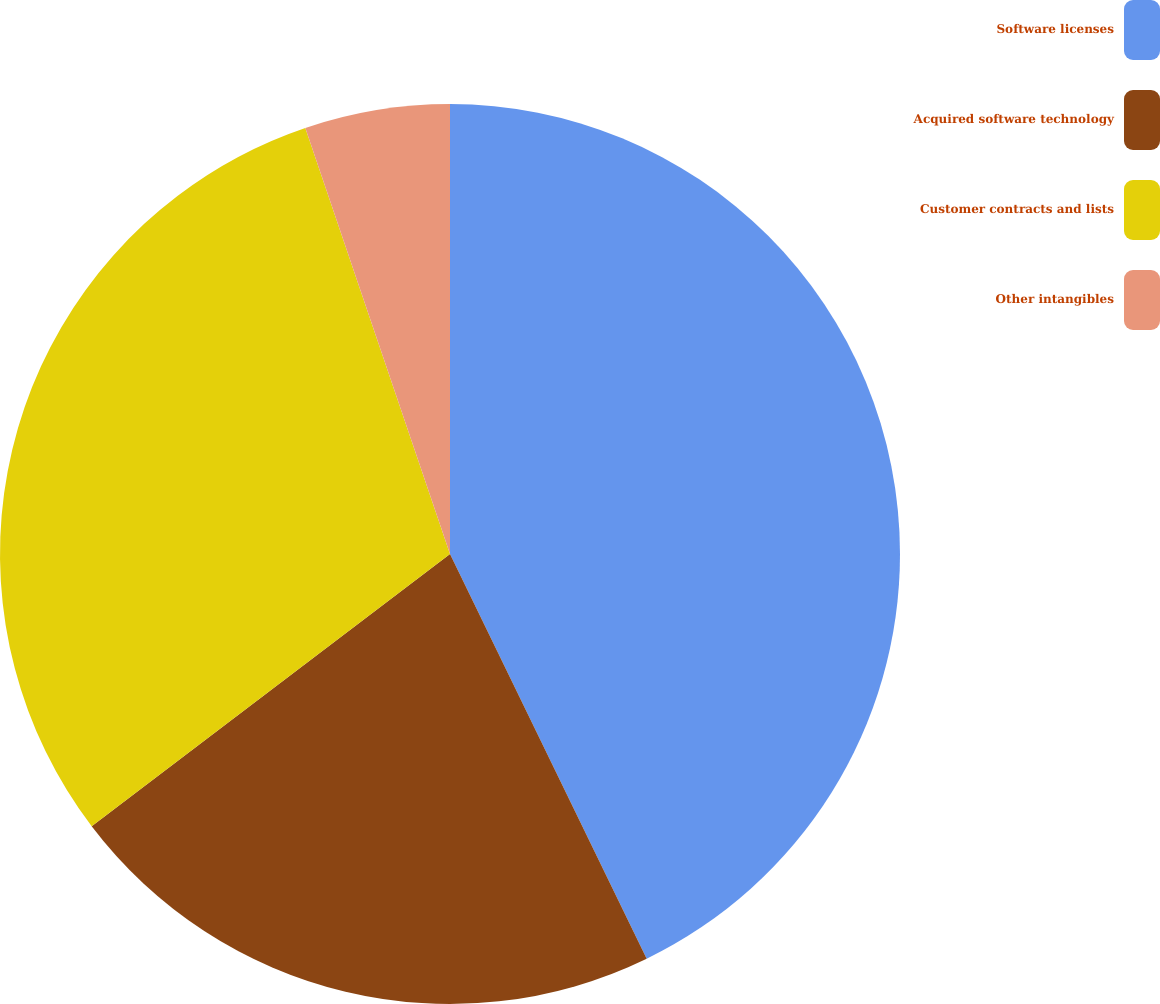Convert chart to OTSL. <chart><loc_0><loc_0><loc_500><loc_500><pie_chart><fcel>Software licenses<fcel>Acquired software technology<fcel>Customer contracts and lists<fcel>Other intangibles<nl><fcel>42.8%<fcel>21.86%<fcel>30.13%<fcel>5.21%<nl></chart> 